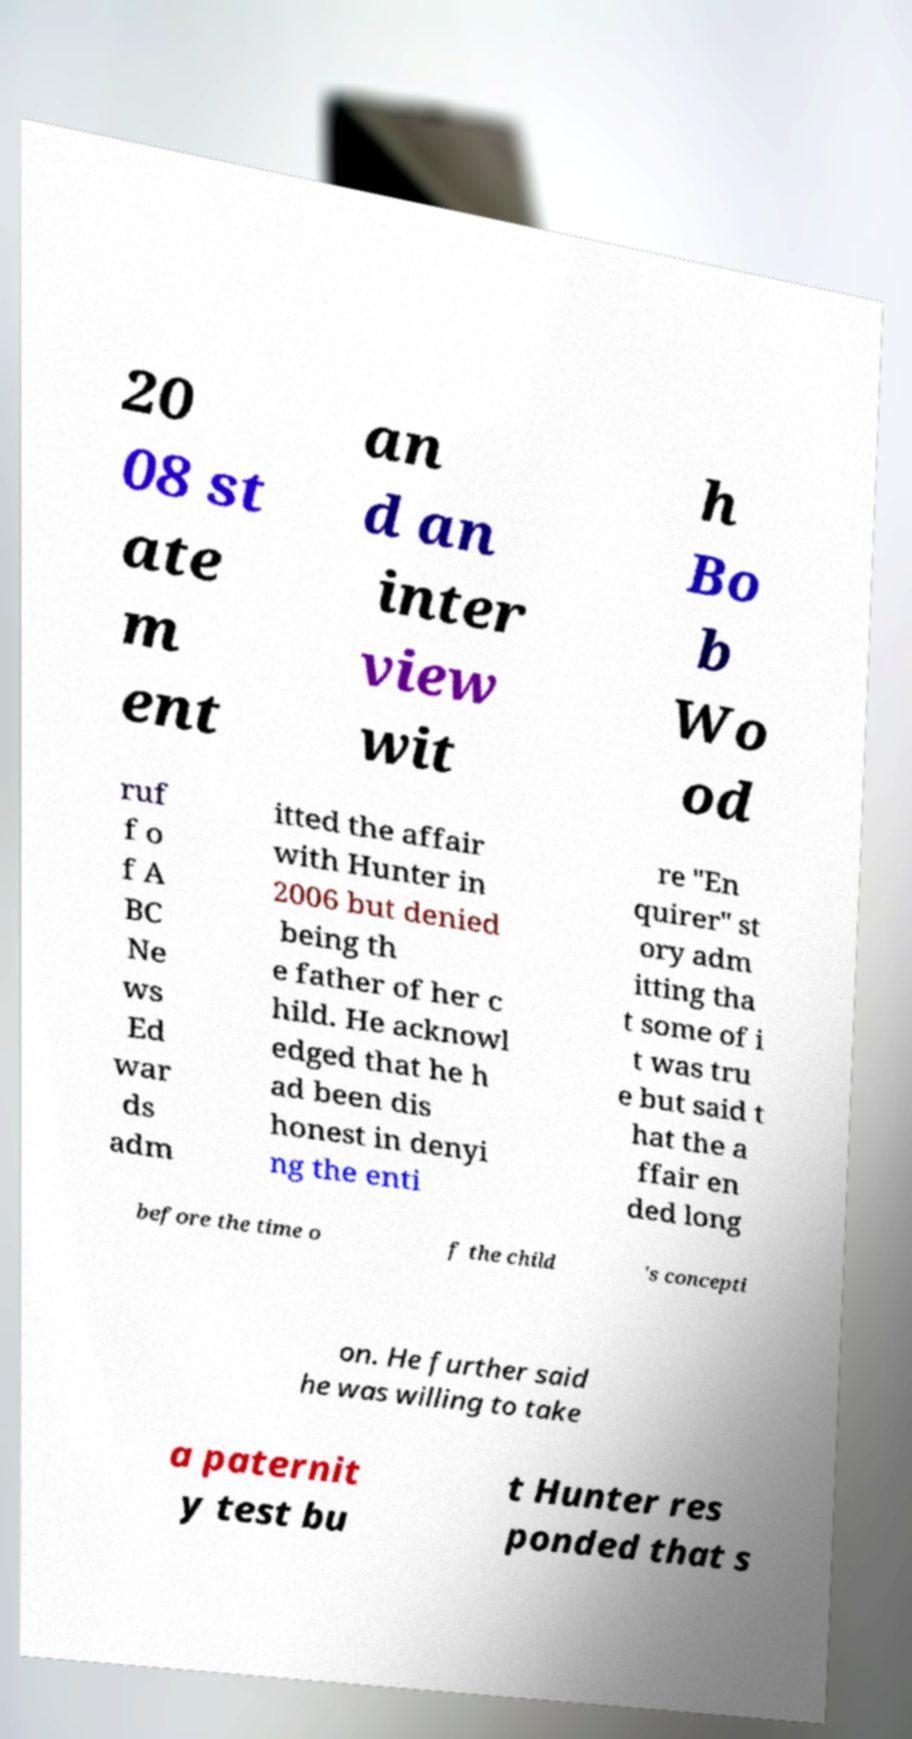Please identify and transcribe the text found in this image. 20 08 st ate m ent an d an inter view wit h Bo b Wo od ruf f o f A BC Ne ws Ed war ds adm itted the affair with Hunter in 2006 but denied being th e father of her c hild. He acknowl edged that he h ad been dis honest in denyi ng the enti re "En quirer" st ory adm itting tha t some of i t was tru e but said t hat the a ffair en ded long before the time o f the child 's concepti on. He further said he was willing to take a paternit y test bu t Hunter res ponded that s 